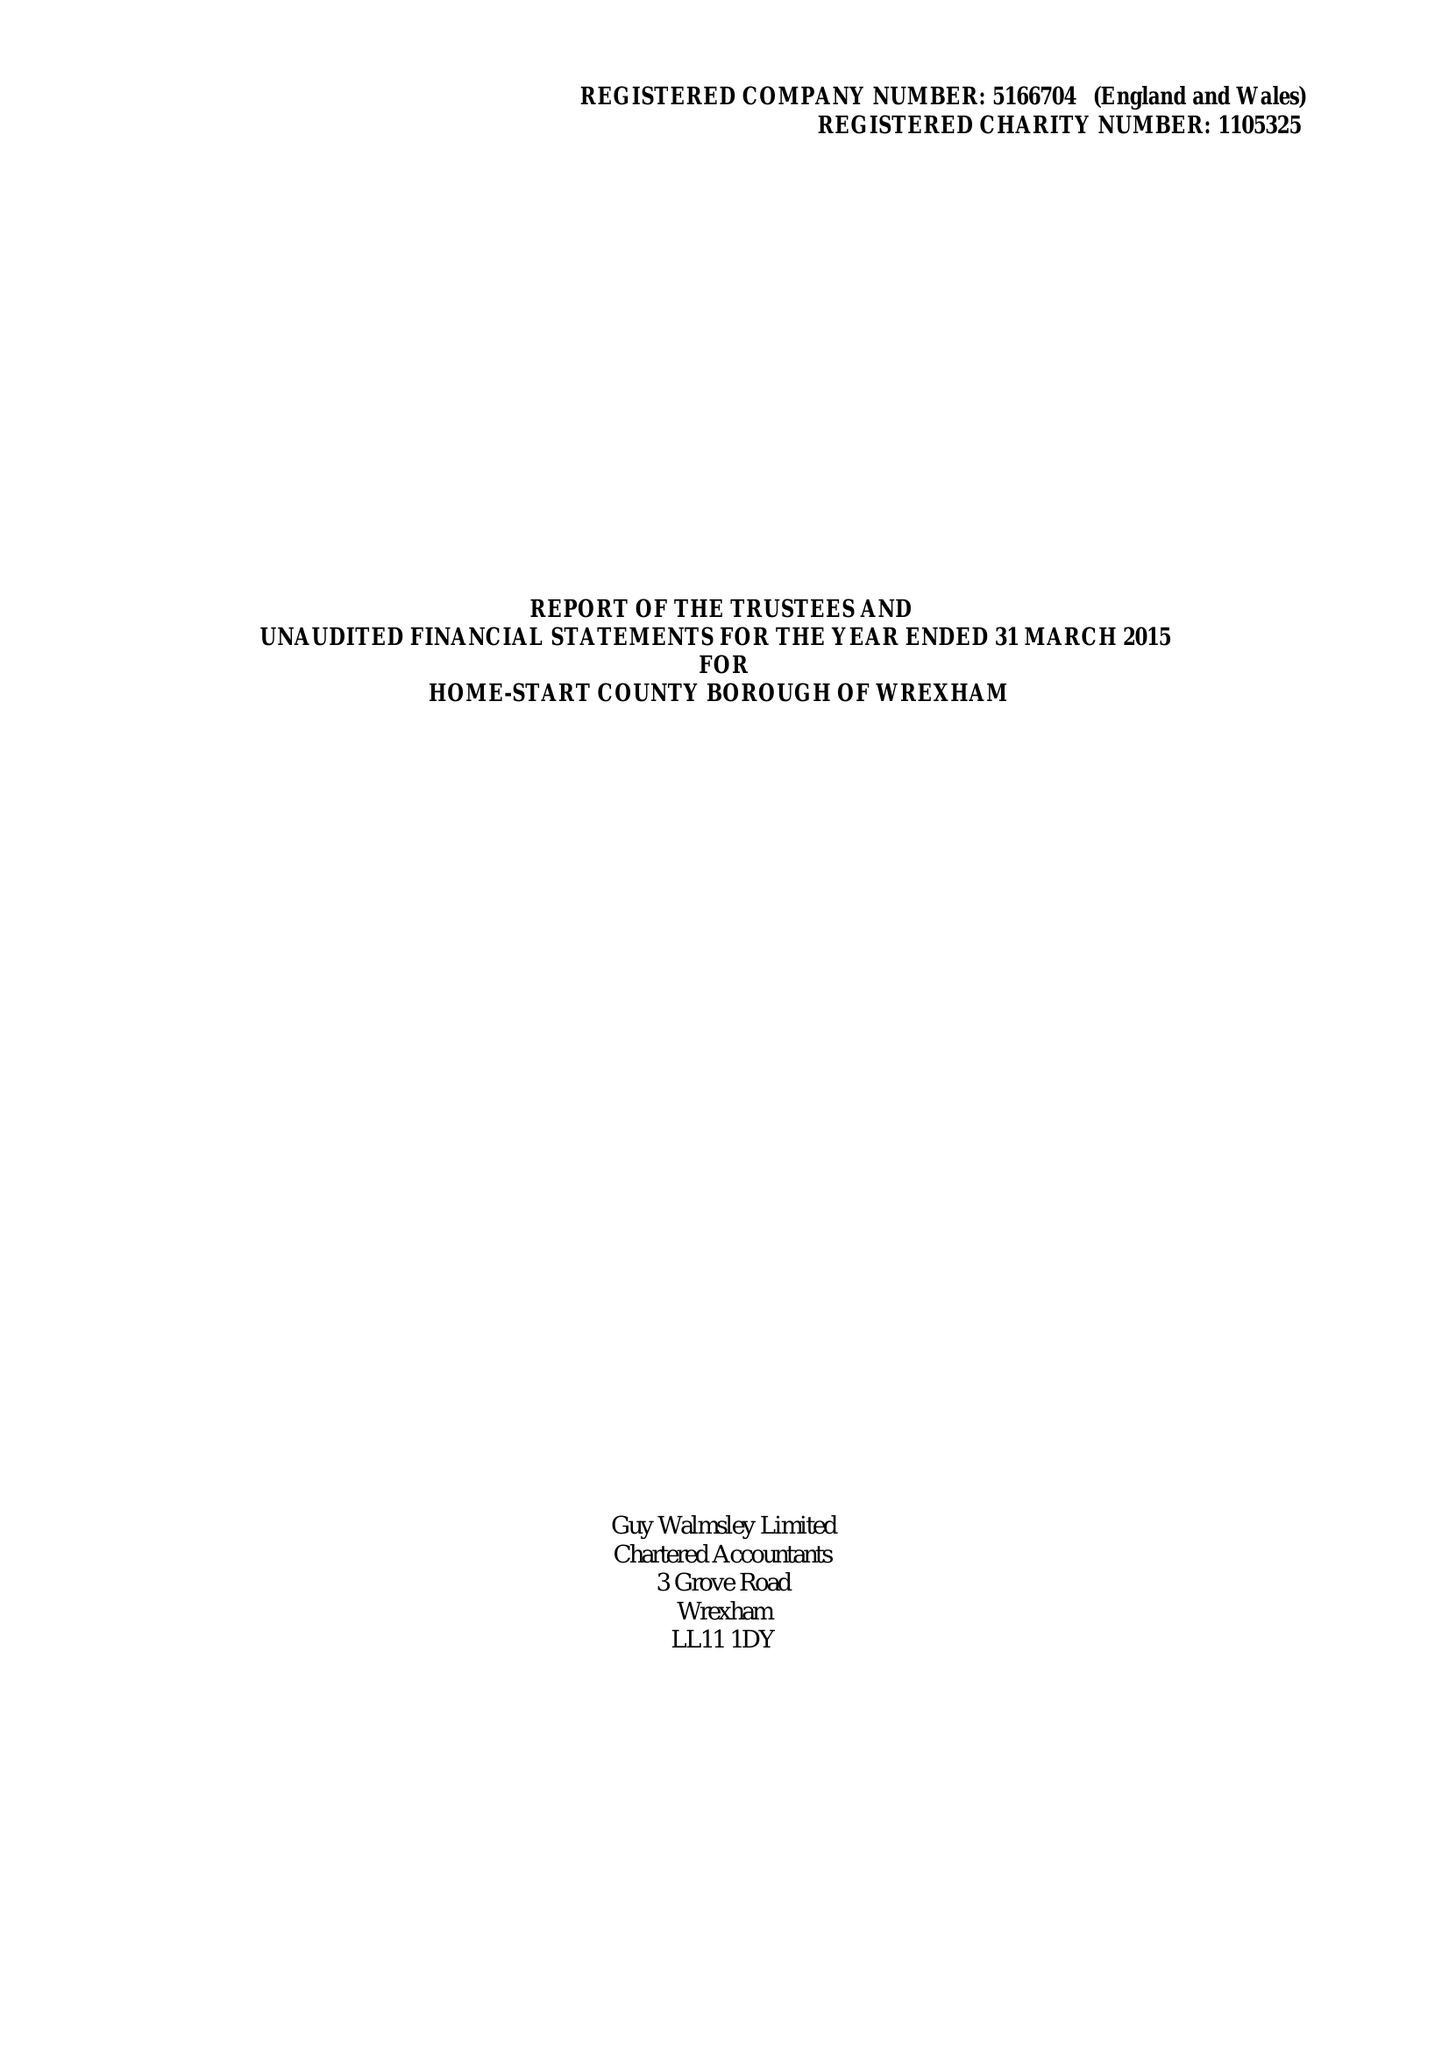What is the value for the spending_annually_in_british_pounds?
Answer the question using a single word or phrase. 174216.00 